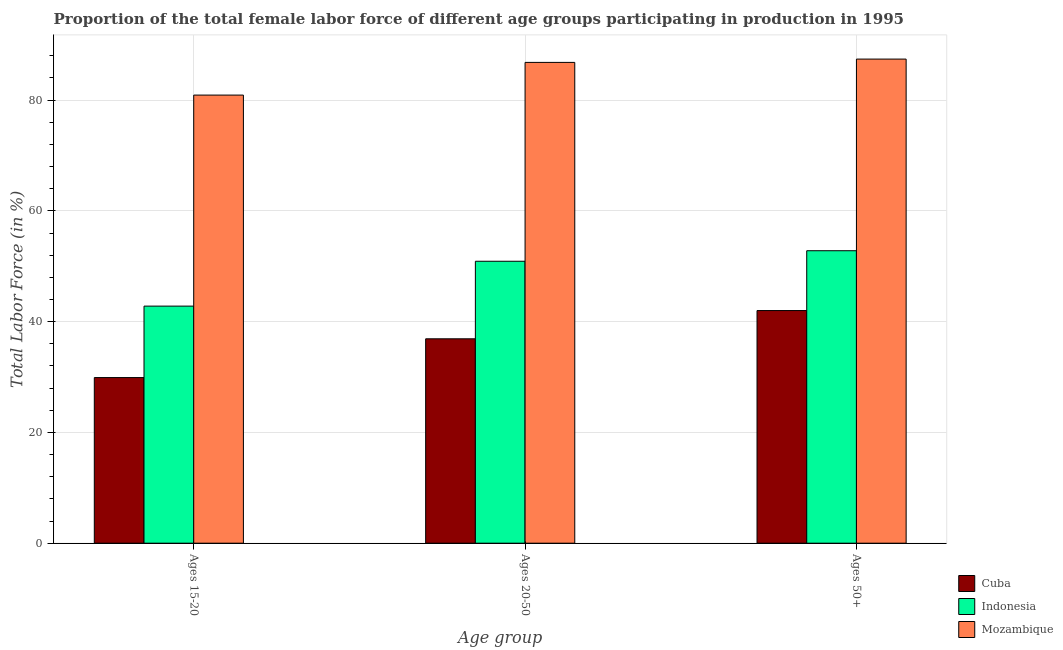How many different coloured bars are there?
Keep it short and to the point. 3. Are the number of bars on each tick of the X-axis equal?
Make the answer very short. Yes. How many bars are there on the 3rd tick from the left?
Keep it short and to the point. 3. How many bars are there on the 1st tick from the right?
Provide a succinct answer. 3. What is the label of the 1st group of bars from the left?
Offer a terse response. Ages 15-20. What is the percentage of female labor force above age 50 in Mozambique?
Make the answer very short. 87.4. Across all countries, what is the maximum percentage of female labor force within the age group 20-50?
Offer a very short reply. 86.8. Across all countries, what is the minimum percentage of female labor force within the age group 20-50?
Offer a terse response. 36.9. In which country was the percentage of female labor force within the age group 15-20 maximum?
Give a very brief answer. Mozambique. In which country was the percentage of female labor force above age 50 minimum?
Your response must be concise. Cuba. What is the total percentage of female labor force within the age group 15-20 in the graph?
Offer a terse response. 153.6. What is the difference between the percentage of female labor force within the age group 20-50 in Mozambique and that in Cuba?
Make the answer very short. 49.9. What is the difference between the percentage of female labor force within the age group 20-50 in Mozambique and the percentage of female labor force above age 50 in Indonesia?
Provide a short and direct response. 34. What is the average percentage of female labor force above age 50 per country?
Offer a terse response. 60.73. What is the difference between the percentage of female labor force within the age group 15-20 and percentage of female labor force above age 50 in Indonesia?
Ensure brevity in your answer.  -10. In how many countries, is the percentage of female labor force within the age group 20-50 greater than 36 %?
Provide a short and direct response. 3. What is the ratio of the percentage of female labor force above age 50 in Indonesia to that in Cuba?
Your response must be concise. 1.26. Is the percentage of female labor force within the age group 15-20 in Mozambique less than that in Cuba?
Make the answer very short. No. What is the difference between the highest and the second highest percentage of female labor force above age 50?
Offer a very short reply. 34.6. What is the difference between the highest and the lowest percentage of female labor force within the age group 15-20?
Your answer should be compact. 51. Is the sum of the percentage of female labor force above age 50 in Cuba and Indonesia greater than the maximum percentage of female labor force within the age group 15-20 across all countries?
Keep it short and to the point. Yes. How many bars are there?
Offer a terse response. 9. What is the difference between two consecutive major ticks on the Y-axis?
Make the answer very short. 20. Does the graph contain grids?
Keep it short and to the point. Yes. Where does the legend appear in the graph?
Offer a very short reply. Bottom right. What is the title of the graph?
Your answer should be compact. Proportion of the total female labor force of different age groups participating in production in 1995. Does "Estonia" appear as one of the legend labels in the graph?
Offer a terse response. No. What is the label or title of the X-axis?
Provide a succinct answer. Age group. What is the label or title of the Y-axis?
Your response must be concise. Total Labor Force (in %). What is the Total Labor Force (in %) of Cuba in Ages 15-20?
Your answer should be very brief. 29.9. What is the Total Labor Force (in %) of Indonesia in Ages 15-20?
Give a very brief answer. 42.8. What is the Total Labor Force (in %) of Mozambique in Ages 15-20?
Ensure brevity in your answer.  80.9. What is the Total Labor Force (in %) in Cuba in Ages 20-50?
Provide a short and direct response. 36.9. What is the Total Labor Force (in %) of Indonesia in Ages 20-50?
Ensure brevity in your answer.  50.9. What is the Total Labor Force (in %) in Mozambique in Ages 20-50?
Ensure brevity in your answer.  86.8. What is the Total Labor Force (in %) in Cuba in Ages 50+?
Give a very brief answer. 42. What is the Total Labor Force (in %) of Indonesia in Ages 50+?
Ensure brevity in your answer.  52.8. What is the Total Labor Force (in %) of Mozambique in Ages 50+?
Your answer should be very brief. 87.4. Across all Age group, what is the maximum Total Labor Force (in %) of Indonesia?
Your answer should be very brief. 52.8. Across all Age group, what is the maximum Total Labor Force (in %) of Mozambique?
Ensure brevity in your answer.  87.4. Across all Age group, what is the minimum Total Labor Force (in %) of Cuba?
Make the answer very short. 29.9. Across all Age group, what is the minimum Total Labor Force (in %) of Indonesia?
Provide a succinct answer. 42.8. Across all Age group, what is the minimum Total Labor Force (in %) in Mozambique?
Your answer should be very brief. 80.9. What is the total Total Labor Force (in %) in Cuba in the graph?
Provide a short and direct response. 108.8. What is the total Total Labor Force (in %) of Indonesia in the graph?
Your response must be concise. 146.5. What is the total Total Labor Force (in %) of Mozambique in the graph?
Make the answer very short. 255.1. What is the difference between the Total Labor Force (in %) of Cuba in Ages 15-20 and that in Ages 20-50?
Your answer should be compact. -7. What is the difference between the Total Labor Force (in %) of Indonesia in Ages 15-20 and that in Ages 20-50?
Give a very brief answer. -8.1. What is the difference between the Total Labor Force (in %) in Mozambique in Ages 20-50 and that in Ages 50+?
Provide a succinct answer. -0.6. What is the difference between the Total Labor Force (in %) in Cuba in Ages 15-20 and the Total Labor Force (in %) in Indonesia in Ages 20-50?
Your answer should be compact. -21. What is the difference between the Total Labor Force (in %) in Cuba in Ages 15-20 and the Total Labor Force (in %) in Mozambique in Ages 20-50?
Provide a succinct answer. -56.9. What is the difference between the Total Labor Force (in %) in Indonesia in Ages 15-20 and the Total Labor Force (in %) in Mozambique in Ages 20-50?
Ensure brevity in your answer.  -44. What is the difference between the Total Labor Force (in %) of Cuba in Ages 15-20 and the Total Labor Force (in %) of Indonesia in Ages 50+?
Offer a very short reply. -22.9. What is the difference between the Total Labor Force (in %) in Cuba in Ages 15-20 and the Total Labor Force (in %) in Mozambique in Ages 50+?
Your answer should be very brief. -57.5. What is the difference between the Total Labor Force (in %) in Indonesia in Ages 15-20 and the Total Labor Force (in %) in Mozambique in Ages 50+?
Provide a succinct answer. -44.6. What is the difference between the Total Labor Force (in %) of Cuba in Ages 20-50 and the Total Labor Force (in %) of Indonesia in Ages 50+?
Your response must be concise. -15.9. What is the difference between the Total Labor Force (in %) of Cuba in Ages 20-50 and the Total Labor Force (in %) of Mozambique in Ages 50+?
Offer a very short reply. -50.5. What is the difference between the Total Labor Force (in %) of Indonesia in Ages 20-50 and the Total Labor Force (in %) of Mozambique in Ages 50+?
Offer a very short reply. -36.5. What is the average Total Labor Force (in %) of Cuba per Age group?
Offer a very short reply. 36.27. What is the average Total Labor Force (in %) in Indonesia per Age group?
Ensure brevity in your answer.  48.83. What is the average Total Labor Force (in %) of Mozambique per Age group?
Make the answer very short. 85.03. What is the difference between the Total Labor Force (in %) in Cuba and Total Labor Force (in %) in Mozambique in Ages 15-20?
Offer a very short reply. -51. What is the difference between the Total Labor Force (in %) of Indonesia and Total Labor Force (in %) of Mozambique in Ages 15-20?
Your answer should be very brief. -38.1. What is the difference between the Total Labor Force (in %) of Cuba and Total Labor Force (in %) of Mozambique in Ages 20-50?
Give a very brief answer. -49.9. What is the difference between the Total Labor Force (in %) in Indonesia and Total Labor Force (in %) in Mozambique in Ages 20-50?
Provide a succinct answer. -35.9. What is the difference between the Total Labor Force (in %) of Cuba and Total Labor Force (in %) of Mozambique in Ages 50+?
Your answer should be compact. -45.4. What is the difference between the Total Labor Force (in %) in Indonesia and Total Labor Force (in %) in Mozambique in Ages 50+?
Keep it short and to the point. -34.6. What is the ratio of the Total Labor Force (in %) of Cuba in Ages 15-20 to that in Ages 20-50?
Keep it short and to the point. 0.81. What is the ratio of the Total Labor Force (in %) in Indonesia in Ages 15-20 to that in Ages 20-50?
Offer a terse response. 0.84. What is the ratio of the Total Labor Force (in %) in Mozambique in Ages 15-20 to that in Ages 20-50?
Your answer should be very brief. 0.93. What is the ratio of the Total Labor Force (in %) of Cuba in Ages 15-20 to that in Ages 50+?
Your answer should be compact. 0.71. What is the ratio of the Total Labor Force (in %) of Indonesia in Ages 15-20 to that in Ages 50+?
Give a very brief answer. 0.81. What is the ratio of the Total Labor Force (in %) in Mozambique in Ages 15-20 to that in Ages 50+?
Offer a very short reply. 0.93. What is the ratio of the Total Labor Force (in %) in Cuba in Ages 20-50 to that in Ages 50+?
Your response must be concise. 0.88. What is the ratio of the Total Labor Force (in %) of Indonesia in Ages 20-50 to that in Ages 50+?
Offer a terse response. 0.96. What is the ratio of the Total Labor Force (in %) of Mozambique in Ages 20-50 to that in Ages 50+?
Your answer should be very brief. 0.99. What is the difference between the highest and the second highest Total Labor Force (in %) in Cuba?
Your answer should be compact. 5.1. What is the difference between the highest and the second highest Total Labor Force (in %) in Indonesia?
Your response must be concise. 1.9. What is the difference between the highest and the second highest Total Labor Force (in %) in Mozambique?
Give a very brief answer. 0.6. What is the difference between the highest and the lowest Total Labor Force (in %) in Indonesia?
Keep it short and to the point. 10. 